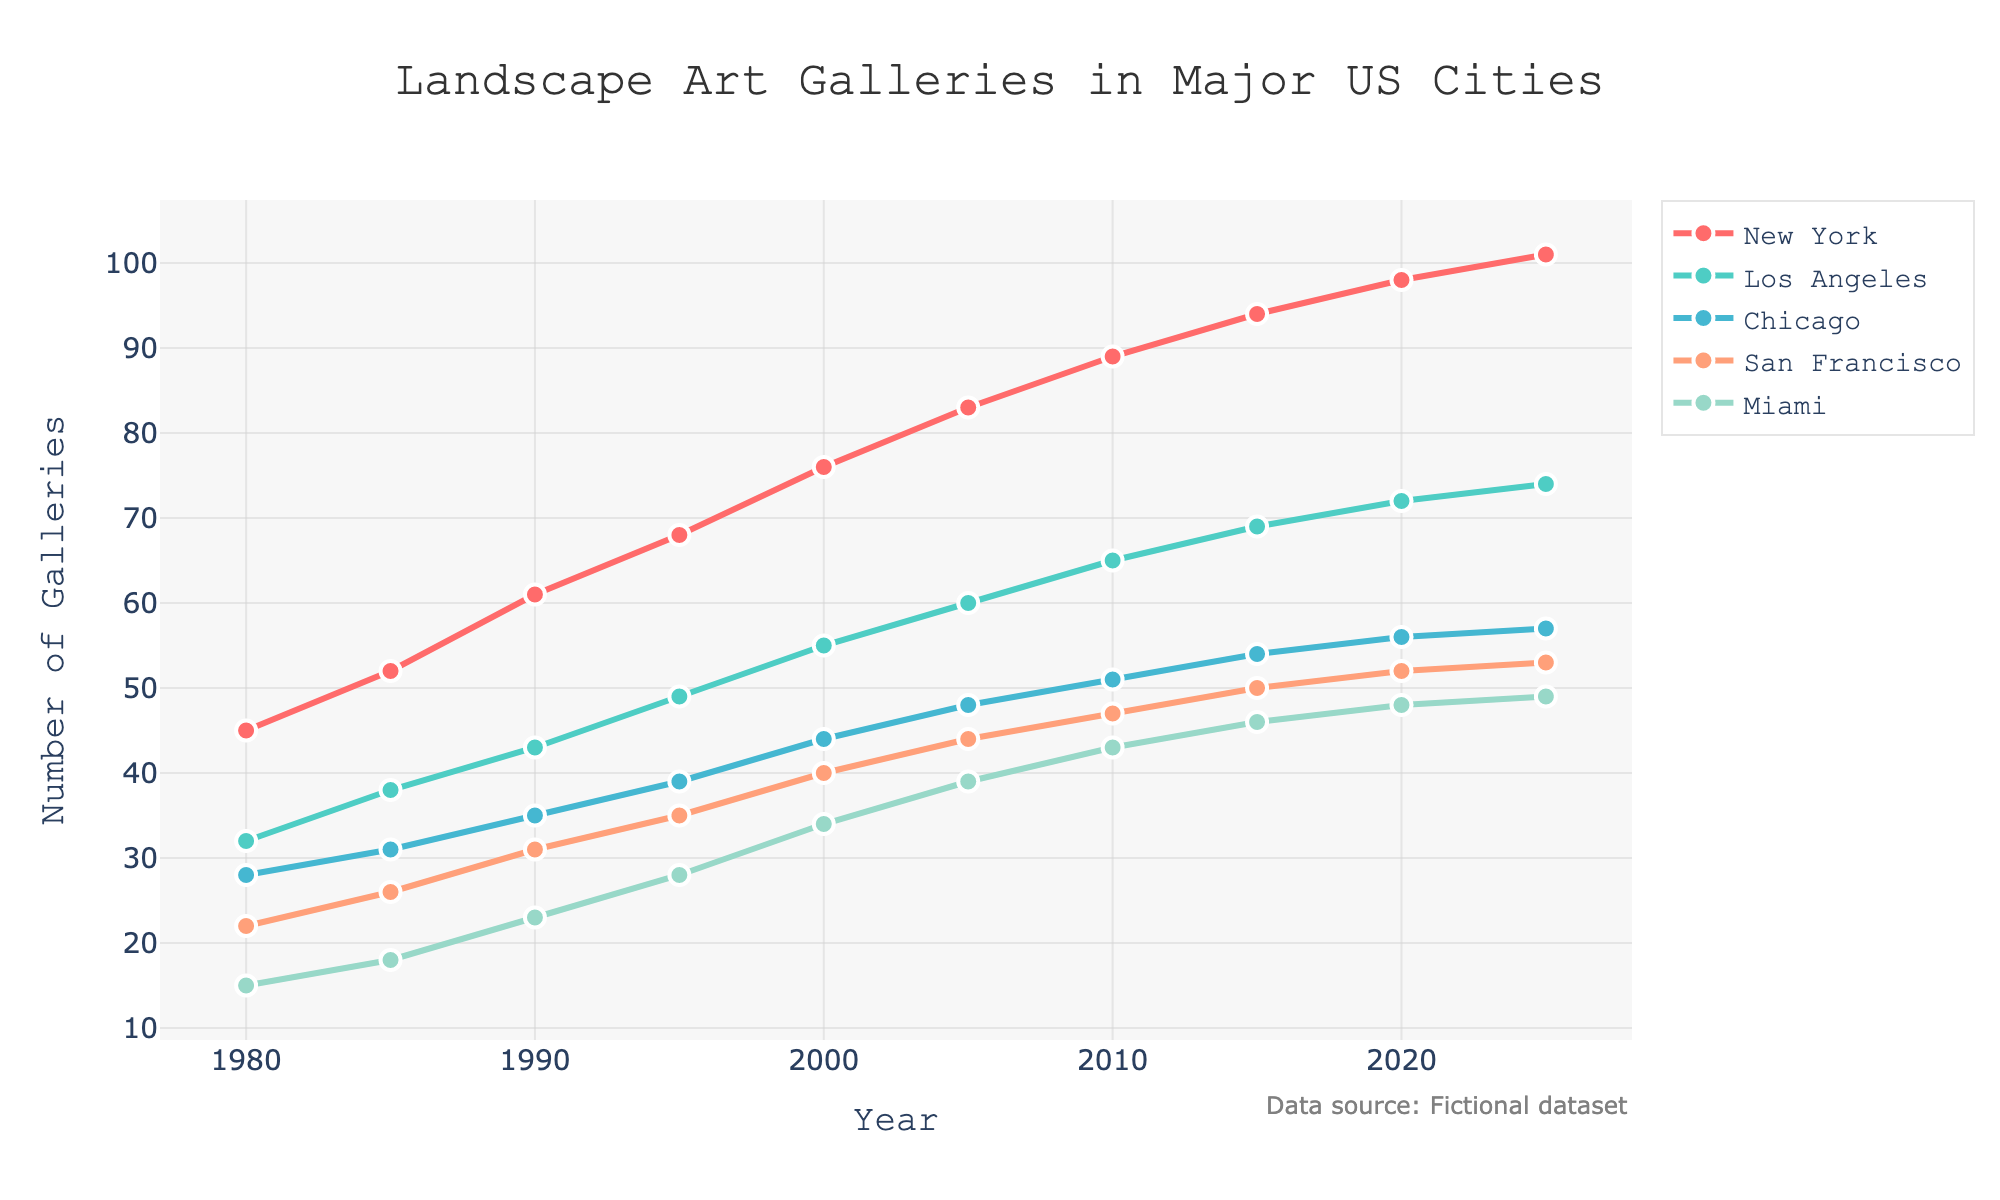What is the overall trend for the number of art galleries in New York from 1980 to 2025? The plot shows a consistent increase in the number of art galleries in New York over the years. From 1980 to 2025, the number of galleries rises from 45 to 101. This indicates a positive, upward trend over the period.
Answer: Upward trend Which city had the highest number of art galleries in 2020? In 2020, the plot shows New York having the highest number of art galleries at 98.
Answer: New York Compare the number of art galleries in Chicago and Miami in 1990. Which city had more, and by how many? In 1990, Chicago had 35 galleries and Miami had 23 galleries. Therefore, Chicago had 12 more galleries than Miami.
Answer: Chicago, by 12 galleries Between 1980 and 2025, which city showed the greatest increase in the number of art galleries? New York had an increase from 45 galleries in 1980 to 101 in 2025, which is the largest increase of 56 galleries when compared to other cities.
Answer: New York What is the average number of art galleries in Los Angeles from 1980 to 2025? The values for Los Angeles are: 32, 38, 43, 49, 55, 60, 65, 69, 72, 74. Summing these gives 557. Dividing by the number of years (10) gives an average of 55.7.
Answer: 55.7 Which two cities had the closest number of art galleries in 2025? In 2025, San Francisco had 53 galleries and Miami had 49 galleries. The difference is 4, which is smaller than the differences between any other two cities for that year.
Answer: San Francisco and Miami What is the total number of art galleries combined for all cities in 2010? The numbers for 2010 are: New York = 89, Los Angeles = 65, Chicago = 51, San Francisco = 47, Miami = 43. Summing these gives 295 galleries.
Answer: 295 How much did the number of art galleries in San Francisco increase from 2000 to 2015? In 2000, San Francisco had 40 galleries, and in 2015, it had 50. The increase is 10 galleries.
Answer: 10 Which year shows the most rapid increase in the number of galleries for New York? Comparing the year-to-year differences: the highest one is between 1990 (61) and 1995 (68), where the increase is 7 galleries.
Answer: 1990 to 1995 Looking at the color representation on the plot, which city is represented by the blue line? The blue line corresponds to San Francisco.
Answer: San Francisco 